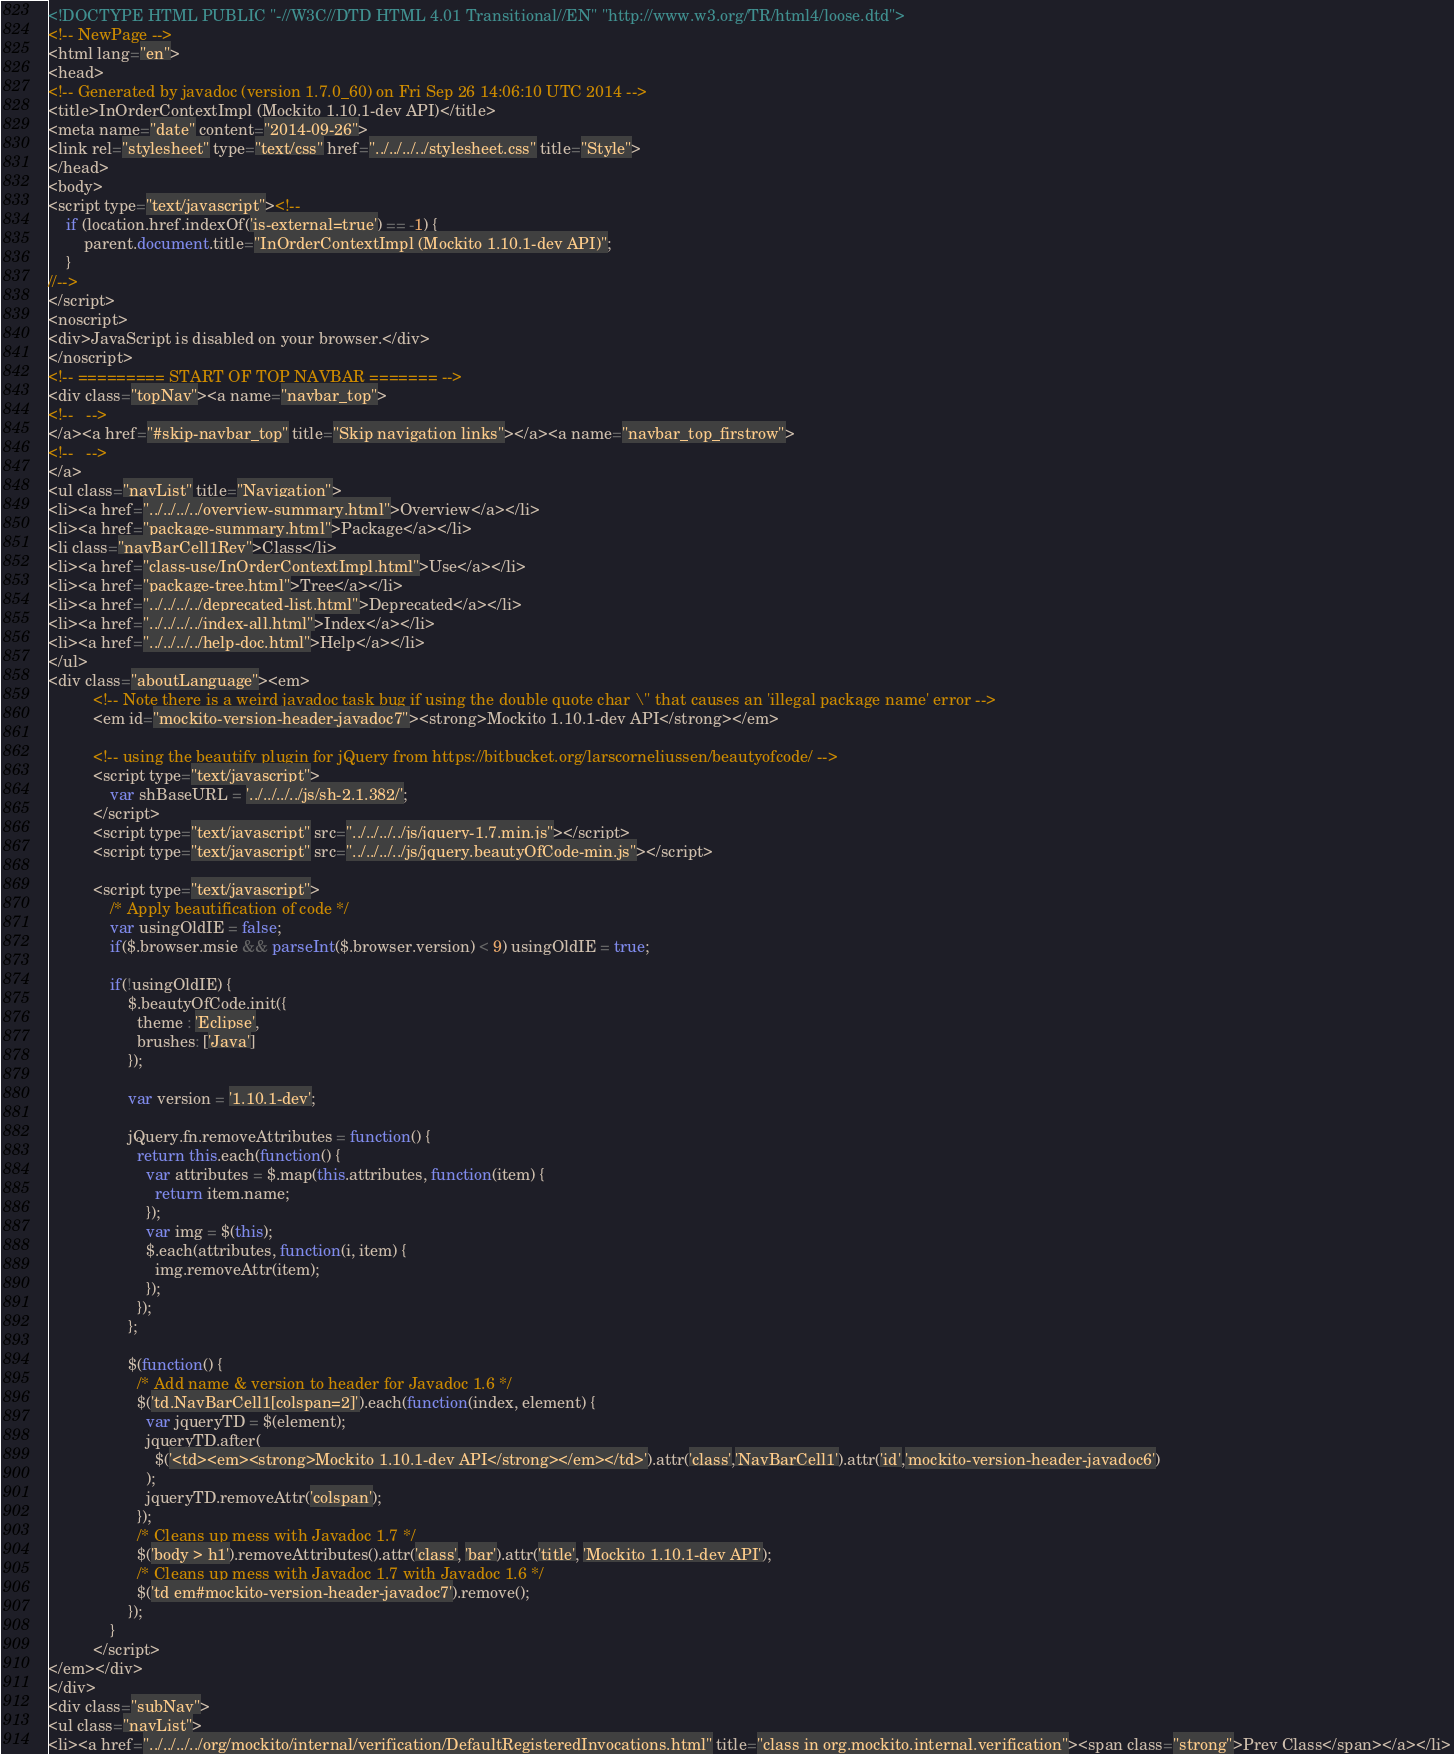<code> <loc_0><loc_0><loc_500><loc_500><_HTML_><!DOCTYPE HTML PUBLIC "-//W3C//DTD HTML 4.01 Transitional//EN" "http://www.w3.org/TR/html4/loose.dtd">
<!-- NewPage -->
<html lang="en">
<head>
<!-- Generated by javadoc (version 1.7.0_60) on Fri Sep 26 14:06:10 UTC 2014 -->
<title>InOrderContextImpl (Mockito 1.10.1-dev API)</title>
<meta name="date" content="2014-09-26">
<link rel="stylesheet" type="text/css" href="../../../../stylesheet.css" title="Style">
</head>
<body>
<script type="text/javascript"><!--
    if (location.href.indexOf('is-external=true') == -1) {
        parent.document.title="InOrderContextImpl (Mockito 1.10.1-dev API)";
    }
//-->
</script>
<noscript>
<div>JavaScript is disabled on your browser.</div>
</noscript>
<!-- ========= START OF TOP NAVBAR ======= -->
<div class="topNav"><a name="navbar_top">
<!--   -->
</a><a href="#skip-navbar_top" title="Skip navigation links"></a><a name="navbar_top_firstrow">
<!--   -->
</a>
<ul class="navList" title="Navigation">
<li><a href="../../../../overview-summary.html">Overview</a></li>
<li><a href="package-summary.html">Package</a></li>
<li class="navBarCell1Rev">Class</li>
<li><a href="class-use/InOrderContextImpl.html">Use</a></li>
<li><a href="package-tree.html">Tree</a></li>
<li><a href="../../../../deprecated-list.html">Deprecated</a></li>
<li><a href="../../../../index-all.html">Index</a></li>
<li><a href="../../../../help-doc.html">Help</a></li>
</ul>
<div class="aboutLanguage"><em>
          <!-- Note there is a weird javadoc task bug if using the double quote char \" that causes an 'illegal package name' error -->
          <em id="mockito-version-header-javadoc7"><strong>Mockito 1.10.1-dev API</strong></em>

          <!-- using the beautify plugin for jQuery from https://bitbucket.org/larscorneliussen/beautyofcode/ -->
          <script type="text/javascript">
              var shBaseURL = '../../../../js/sh-2.1.382/';
          </script>
          <script type="text/javascript" src="../../../../js/jquery-1.7.min.js"></script>
          <script type="text/javascript" src="../../../../js/jquery.beautyOfCode-min.js"></script>

          <script type="text/javascript">
              /* Apply beautification of code */
              var usingOldIE = false;
              if($.browser.msie && parseInt($.browser.version) < 9) usingOldIE = true;

              if(!usingOldIE) {
                  $.beautyOfCode.init({
                    theme : 'Eclipse',
                    brushes: ['Java']
                  });

                  var version = '1.10.1-dev';

                  jQuery.fn.removeAttributes = function() {
                    return this.each(function() {
                      var attributes = $.map(this.attributes, function(item) {
                        return item.name;
                      });
                      var img = $(this);
                      $.each(attributes, function(i, item) {
                        img.removeAttr(item);
                      });
                    });
                  };

                  $(function() {
                    /* Add name & version to header for Javadoc 1.6 */
                    $('td.NavBarCell1[colspan=2]').each(function(index, element) {
                      var jqueryTD = $(element);
                      jqueryTD.after(
                        $('<td><em><strong>Mockito 1.10.1-dev API</strong></em></td>').attr('class','NavBarCell1').attr('id','mockito-version-header-javadoc6')
                      );
                      jqueryTD.removeAttr('colspan');
                    });
                    /* Cleans up mess with Javadoc 1.7 */
                    $('body > h1').removeAttributes().attr('class', 'bar').attr('title', 'Mockito 1.10.1-dev API');
                    /* Cleans up mess with Javadoc 1.7 with Javadoc 1.6 */
                    $('td em#mockito-version-header-javadoc7').remove();
                  });
              }
          </script>
</em></div>
</div>
<div class="subNav">
<ul class="navList">
<li><a href="../../../../org/mockito/internal/verification/DefaultRegisteredInvocations.html" title="class in org.mockito.internal.verification"><span class="strong">Prev Class</span></a></li></code> 